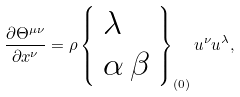<formula> <loc_0><loc_0><loc_500><loc_500>\frac { \partial \Theta ^ { \mu \nu } } { \partial x ^ { \nu } } = \rho \left \{ \begin{array} { l } \lambda \\ \alpha \, \beta \end{array} \right \} _ { ( 0 ) } u ^ { \nu } u ^ { \lambda } ,</formula> 